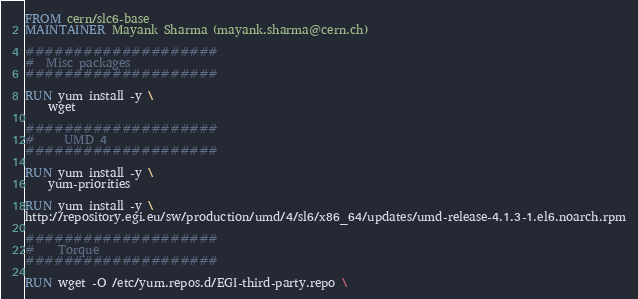<code> <loc_0><loc_0><loc_500><loc_500><_Dockerfile_>FROM cern/slc6-base
MAINTAINER Mayank Sharma (mayank.sharma@cern.ch)

####################
#  Misc packages
####################

RUN yum install -y \
	wget

####################
#     UMD 4
####################

RUN yum install -y \
	yum-priorities

RUN yum install -y \
http://repository.egi.eu/sw/production/umd/4/sl6/x86_64/updates/umd-release-4.1.3-1.el6.noarch.rpm

####################
#    Torque
####################

RUN wget -O /etc/yum.repos.d/EGI-third-party.repo \</code> 